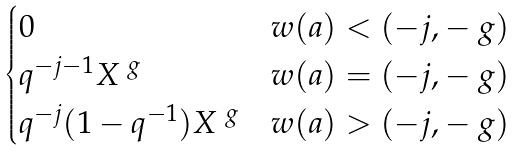Convert formula to latex. <formula><loc_0><loc_0><loc_500><loc_500>\begin{cases} 0 & w ( a ) < ( - j , - \ g ) \\ q ^ { - j - 1 } X ^ { \ g } & w ( a ) = ( - j , - \ g ) \\ q ^ { - j } ( 1 - q ^ { - 1 } ) X ^ { \ g } & w ( a ) > ( - j , - \ g ) \end{cases}</formula> 